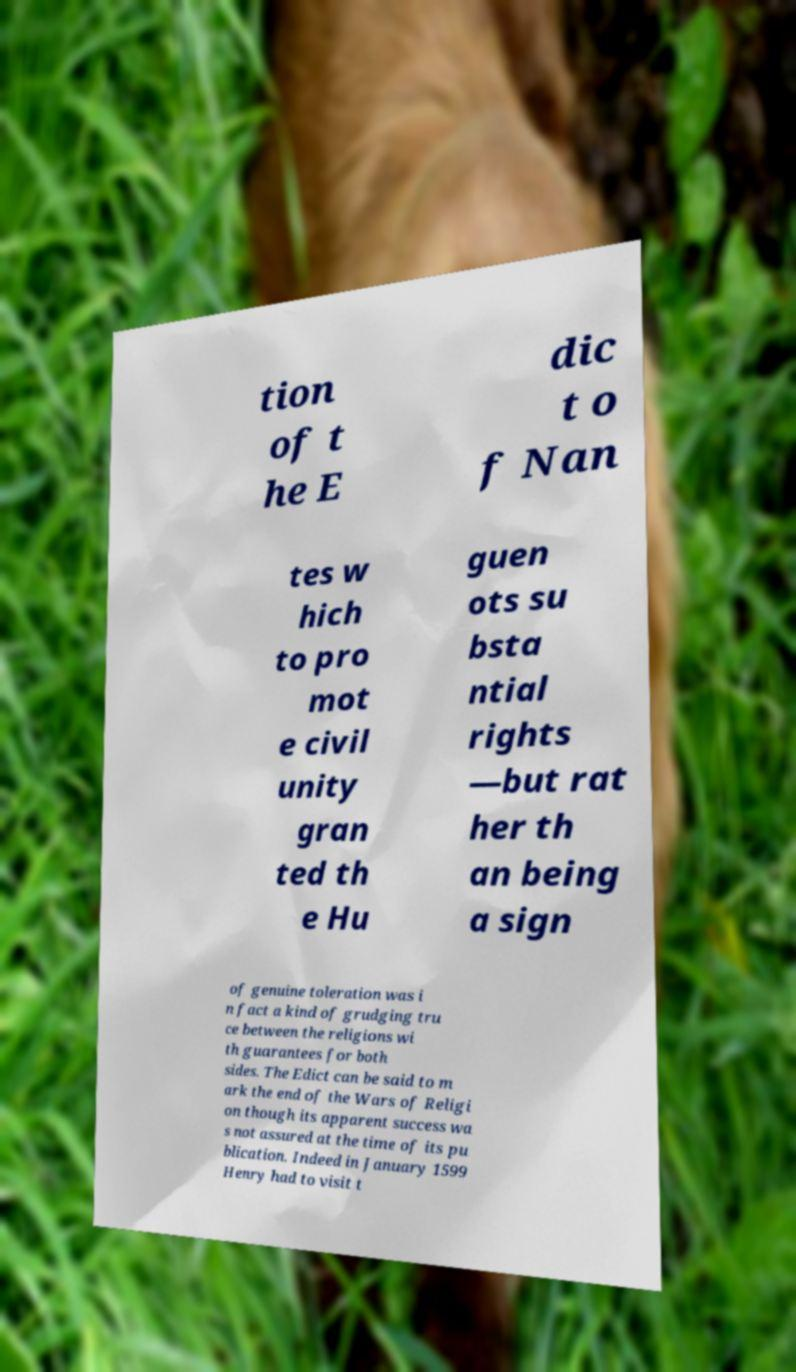Please read and relay the text visible in this image. What does it say? tion of t he E dic t o f Nan tes w hich to pro mot e civil unity gran ted th e Hu guen ots su bsta ntial rights —but rat her th an being a sign of genuine toleration was i n fact a kind of grudging tru ce between the religions wi th guarantees for both sides. The Edict can be said to m ark the end of the Wars of Religi on though its apparent success wa s not assured at the time of its pu blication. Indeed in January 1599 Henry had to visit t 